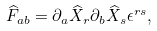<formula> <loc_0><loc_0><loc_500><loc_500>\widehat { F } _ { a b } = \partial _ { a } \widehat { X } _ { r } \partial _ { b } \widehat { X } _ { s } \epsilon ^ { r s } ,</formula> 